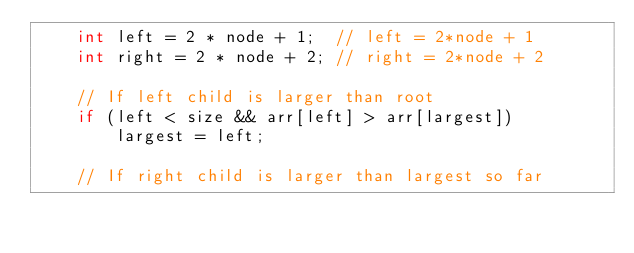<code> <loc_0><loc_0><loc_500><loc_500><_C++_>    int left = 2 * node + 1;  // left = 2*node + 1
    int right = 2 * node + 2; // right = 2*node + 2

    // If left child is larger than root
    if (left < size && arr[left] > arr[largest])
        largest = left;

    // If right child is larger than largest so far</code> 